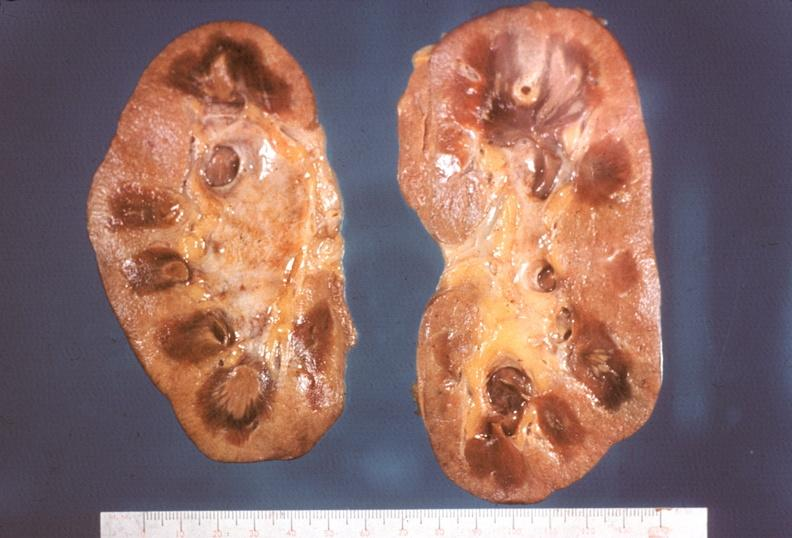where is this?
Answer the question using a single word or phrase. Urinary 